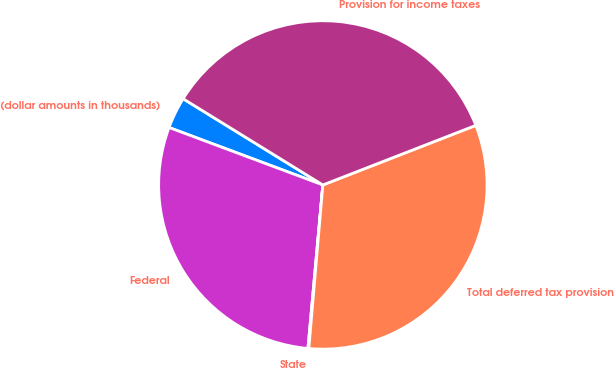<chart> <loc_0><loc_0><loc_500><loc_500><pie_chart><fcel>(dollar amounts in thousands)<fcel>Federal<fcel>State<fcel>Total deferred tax provision<fcel>Provision for income taxes<nl><fcel>3.11%<fcel>29.24%<fcel>0.09%<fcel>32.27%<fcel>35.29%<nl></chart> 